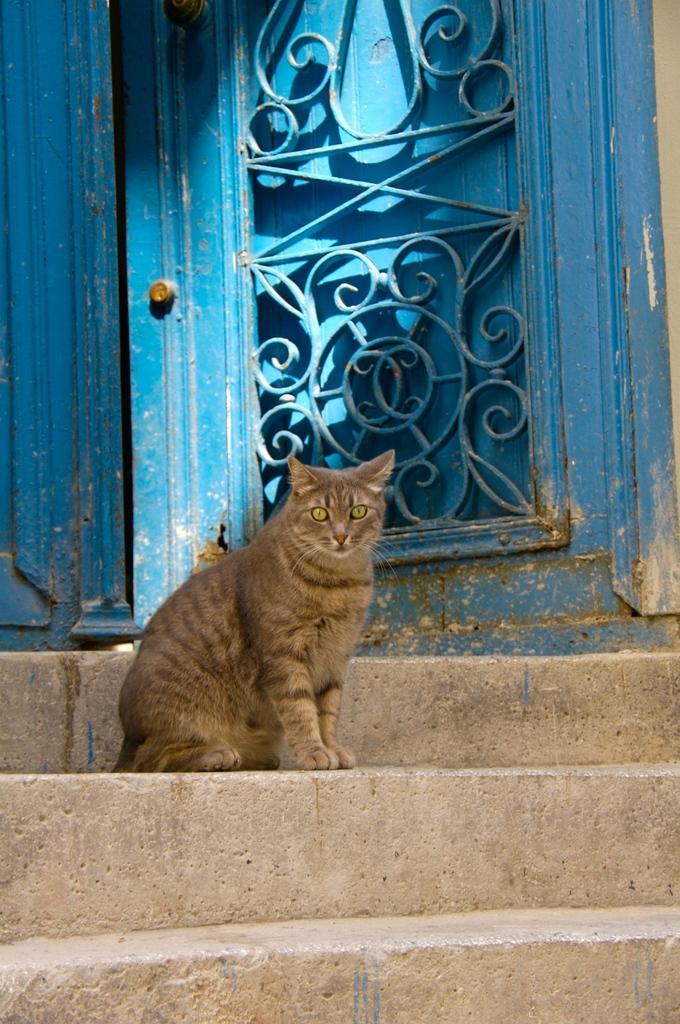Could you give a brief overview of what you see in this image? In this picture there is a cat on the staircase. At the back there is a door and the door is in blue color. 